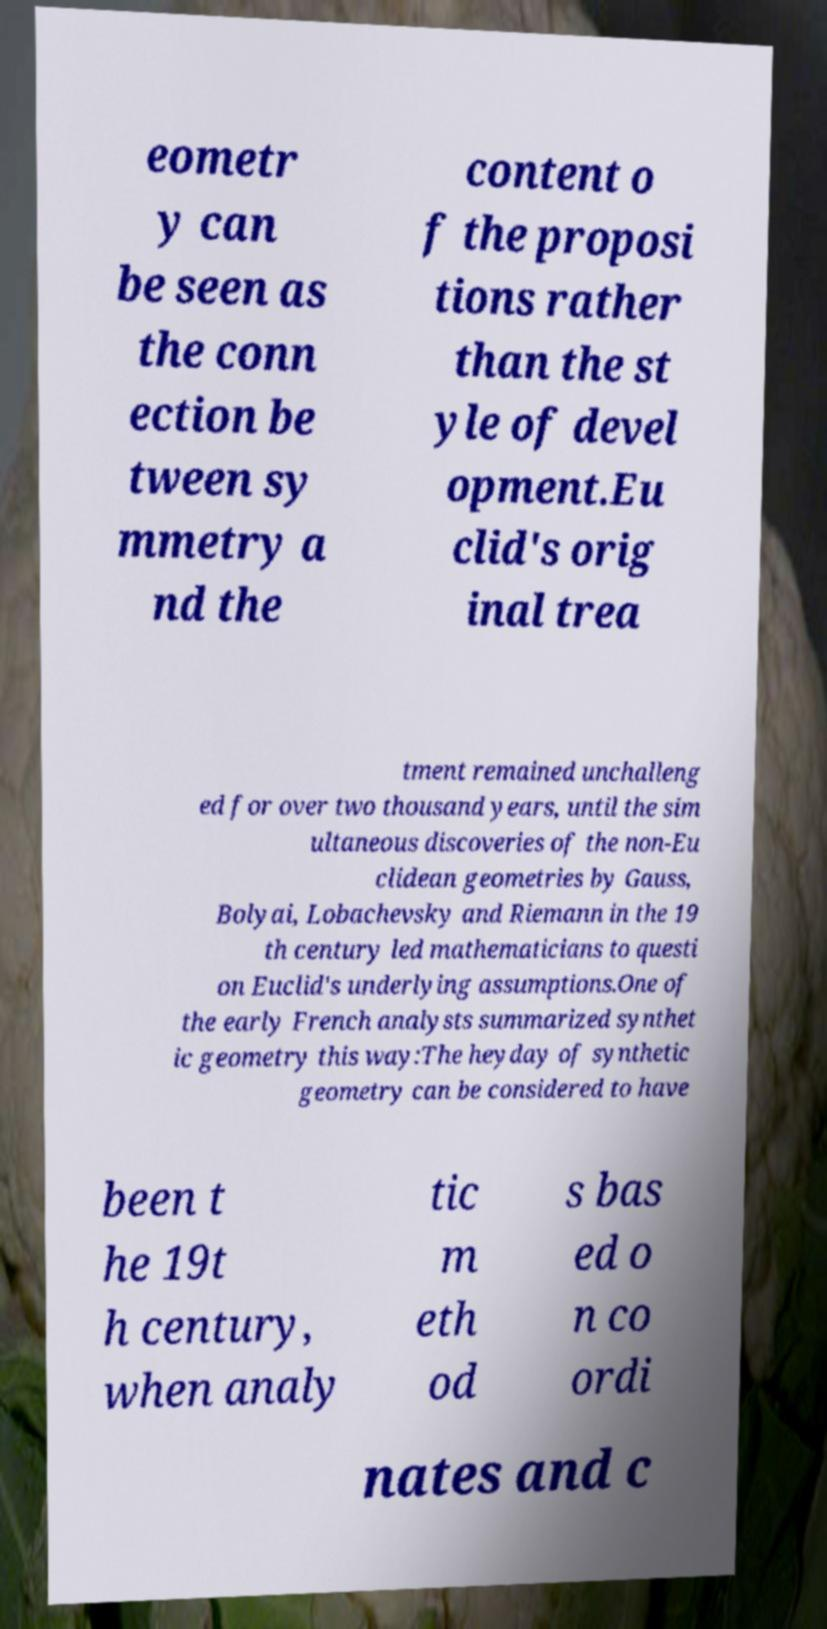What messages or text are displayed in this image? I need them in a readable, typed format. eometr y can be seen as the conn ection be tween sy mmetry a nd the content o f the proposi tions rather than the st yle of devel opment.Eu clid's orig inal trea tment remained unchalleng ed for over two thousand years, until the sim ultaneous discoveries of the non-Eu clidean geometries by Gauss, Bolyai, Lobachevsky and Riemann in the 19 th century led mathematicians to questi on Euclid's underlying assumptions.One of the early French analysts summarized synthet ic geometry this way:The heyday of synthetic geometry can be considered to have been t he 19t h century, when analy tic m eth od s bas ed o n co ordi nates and c 